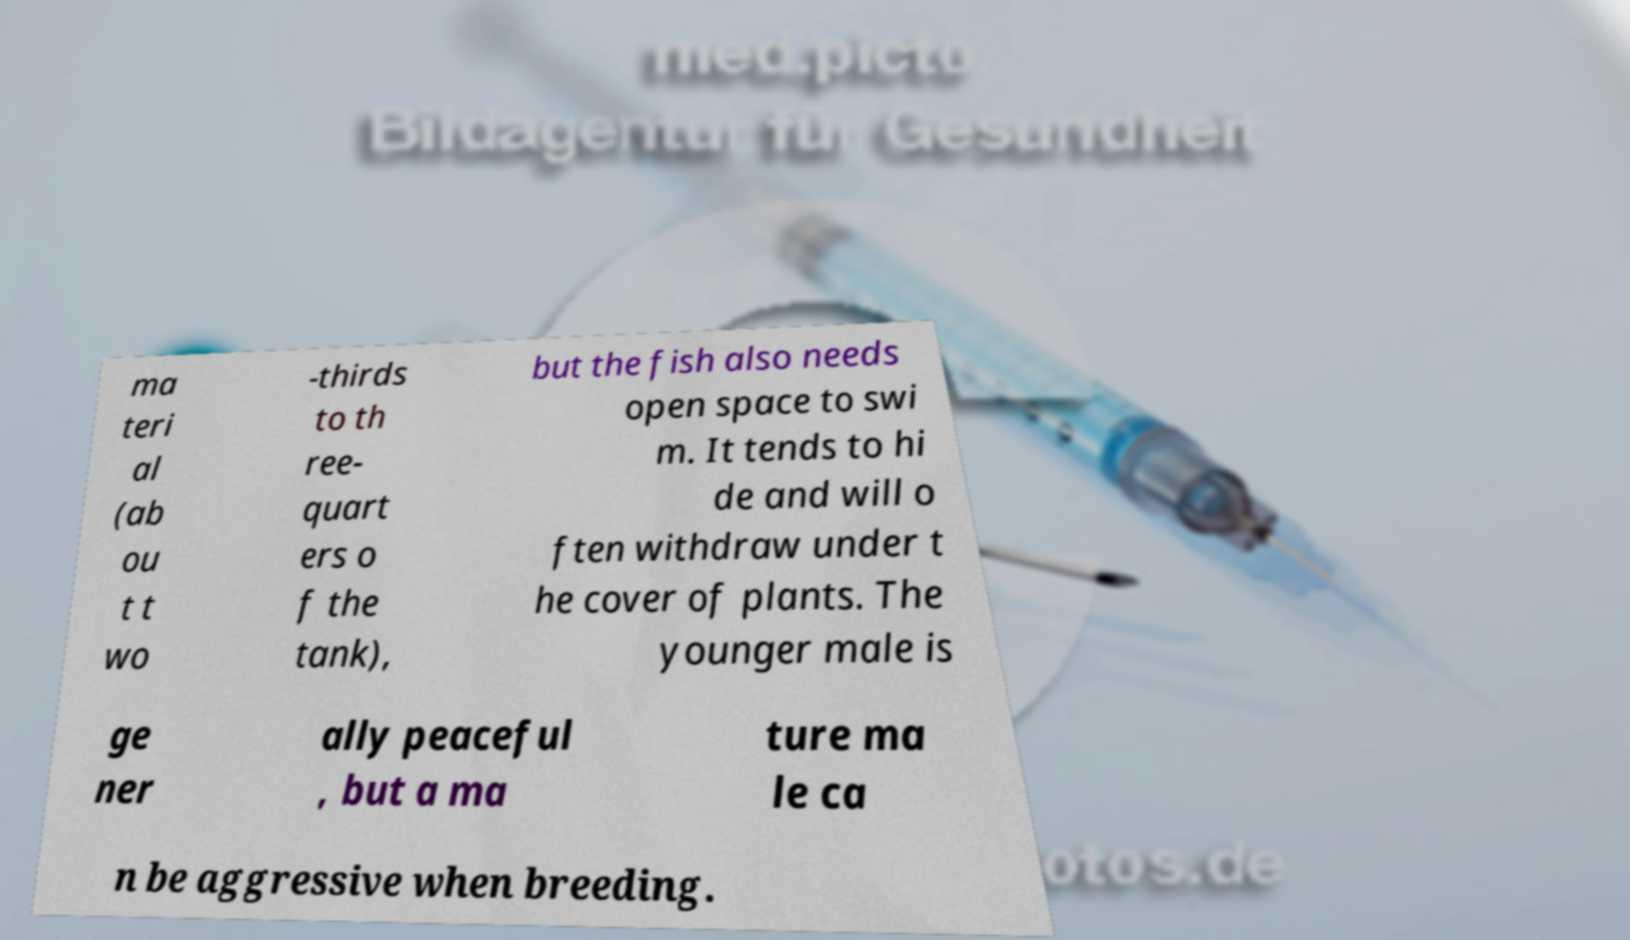There's text embedded in this image that I need extracted. Can you transcribe it verbatim? ma teri al (ab ou t t wo -thirds to th ree- quart ers o f the tank), but the fish also needs open space to swi m. It tends to hi de and will o ften withdraw under t he cover of plants. The younger male is ge ner ally peaceful , but a ma ture ma le ca n be aggressive when breeding. 